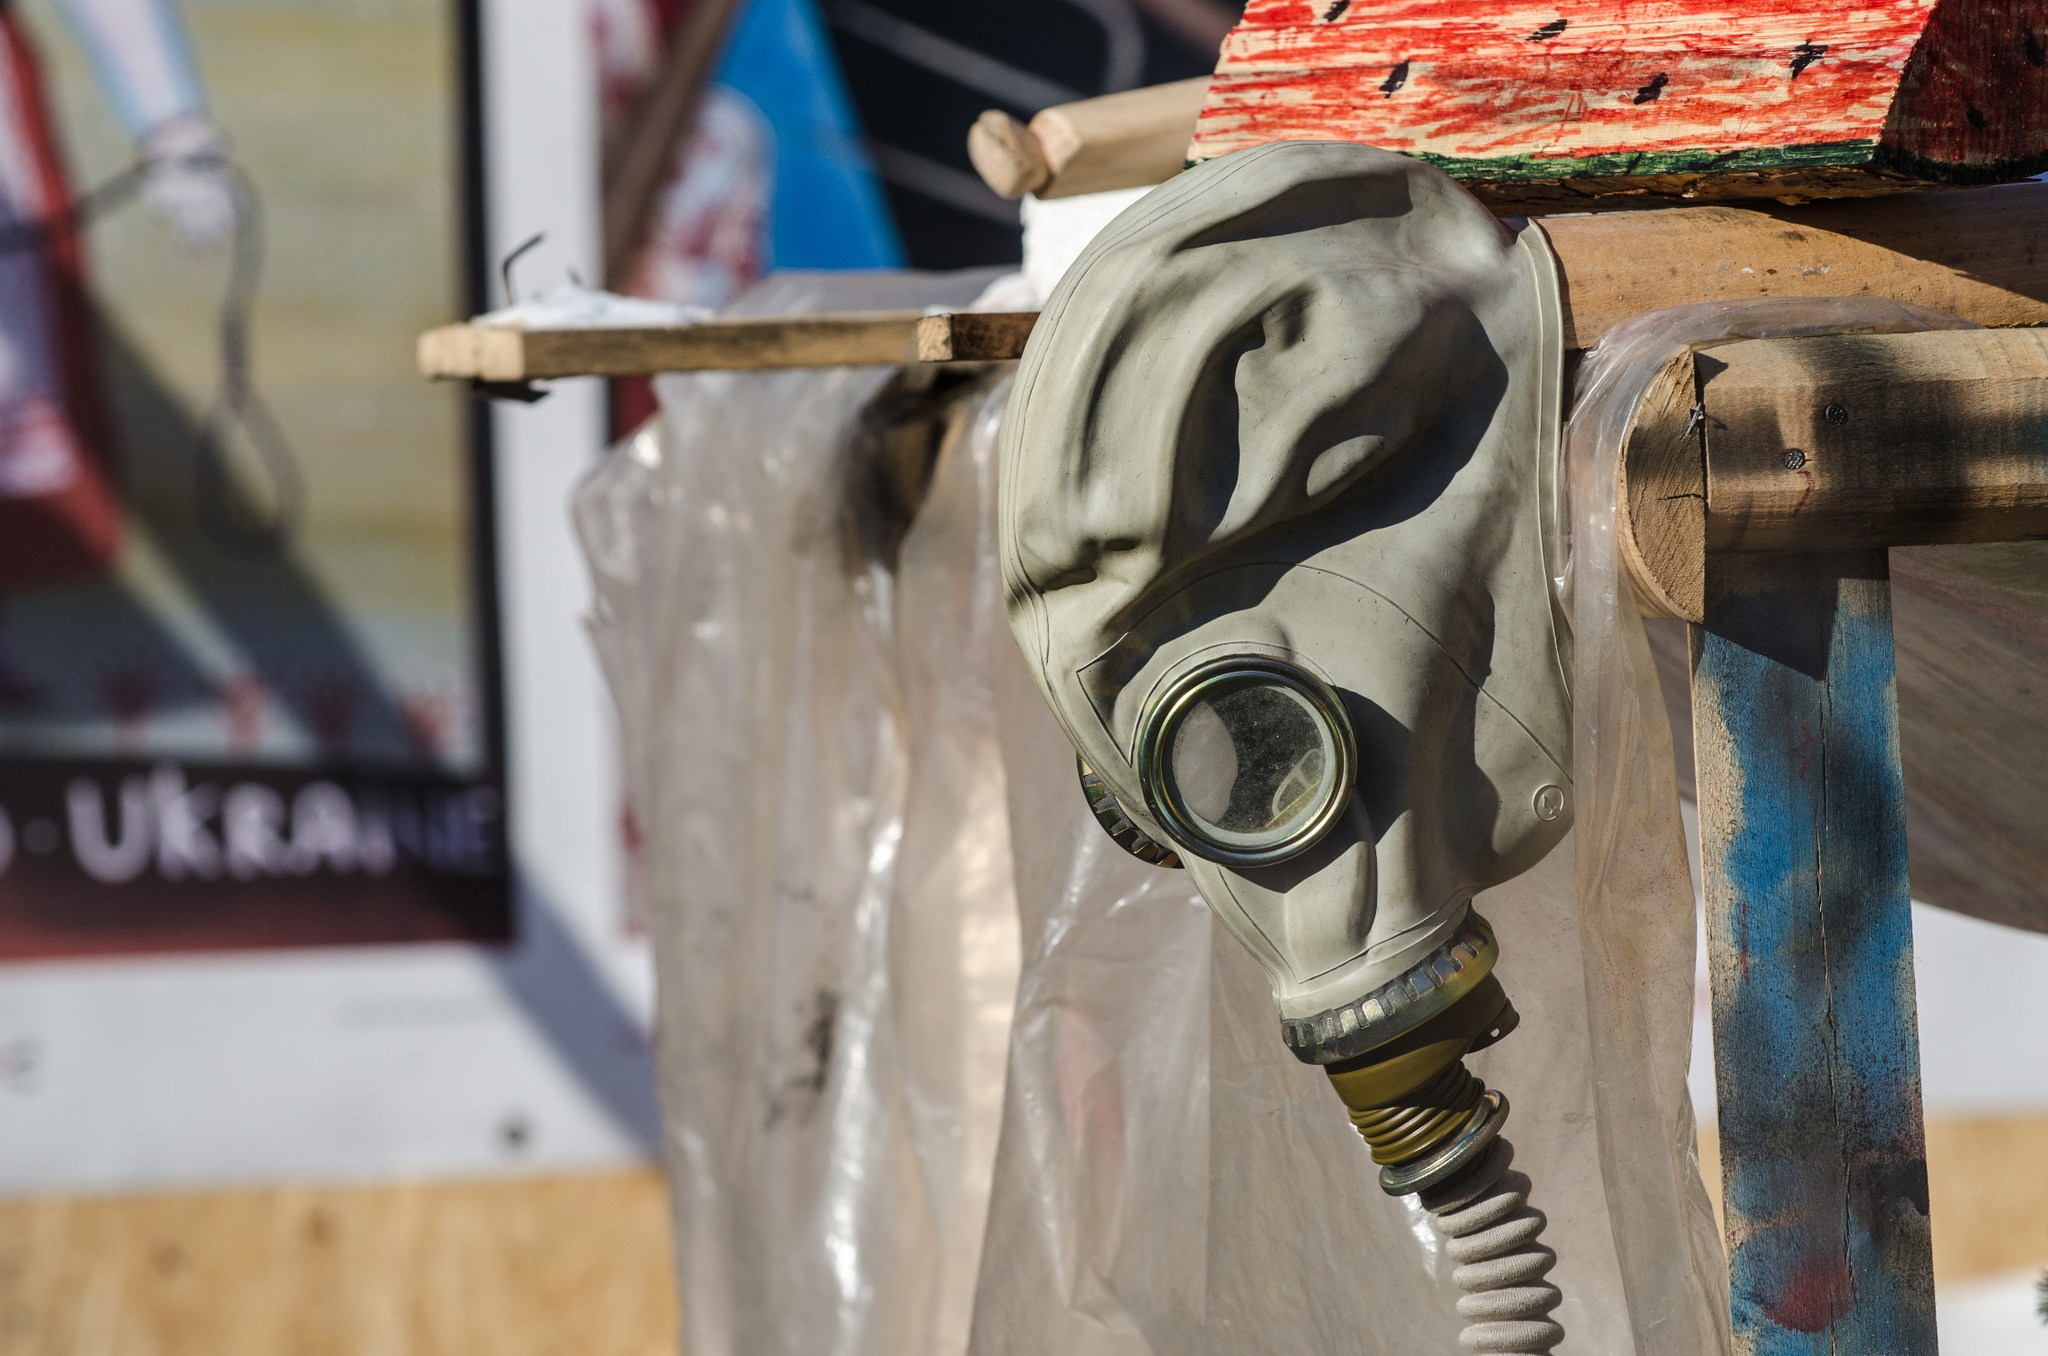What can you infer about the purpose of exhibiting this gas mask in such a manner? The exhibition of the gas mask in this manner could signify a tribute to historical events where such equipment was crucial, possibly during conflicts or chemical emergencies. By displaying it publicly and prominently, it acts as a stark reminder of the past struggles and serves an educational purpose to inform visitors about the essential protective gear used in hazardous situations. 